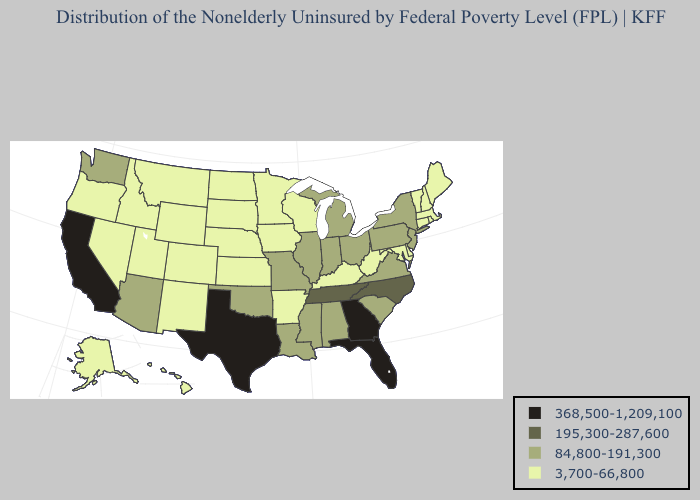What is the lowest value in the MidWest?
Quick response, please. 3,700-66,800. Does Michigan have the lowest value in the MidWest?
Keep it brief. No. Does Iowa have a lower value than Florida?
Give a very brief answer. Yes. Name the states that have a value in the range 3,700-66,800?
Quick response, please. Alaska, Arkansas, Colorado, Connecticut, Delaware, Hawaii, Idaho, Iowa, Kansas, Kentucky, Maine, Maryland, Massachusetts, Minnesota, Montana, Nebraska, Nevada, New Hampshire, New Mexico, North Dakota, Oregon, Rhode Island, South Dakota, Utah, Vermont, West Virginia, Wisconsin, Wyoming. Among the states that border Virginia , does West Virginia have the highest value?
Short answer required. No. Name the states that have a value in the range 84,800-191,300?
Keep it brief. Alabama, Arizona, Illinois, Indiana, Louisiana, Michigan, Mississippi, Missouri, New Jersey, New York, Ohio, Oklahoma, Pennsylvania, South Carolina, Virginia, Washington. Which states hav the highest value in the MidWest?
Write a very short answer. Illinois, Indiana, Michigan, Missouri, Ohio. Does Alabama have the lowest value in the USA?
Short answer required. No. What is the highest value in states that border Louisiana?
Quick response, please. 368,500-1,209,100. Name the states that have a value in the range 368,500-1,209,100?
Answer briefly. California, Florida, Georgia, Texas. What is the value of Connecticut?
Quick response, please. 3,700-66,800. What is the lowest value in the West?
Give a very brief answer. 3,700-66,800. Does Colorado have the lowest value in the West?
Concise answer only. Yes. Name the states that have a value in the range 84,800-191,300?
Quick response, please. Alabama, Arizona, Illinois, Indiana, Louisiana, Michigan, Mississippi, Missouri, New Jersey, New York, Ohio, Oklahoma, Pennsylvania, South Carolina, Virginia, Washington. Does Mississippi have the lowest value in the USA?
Short answer required. No. 